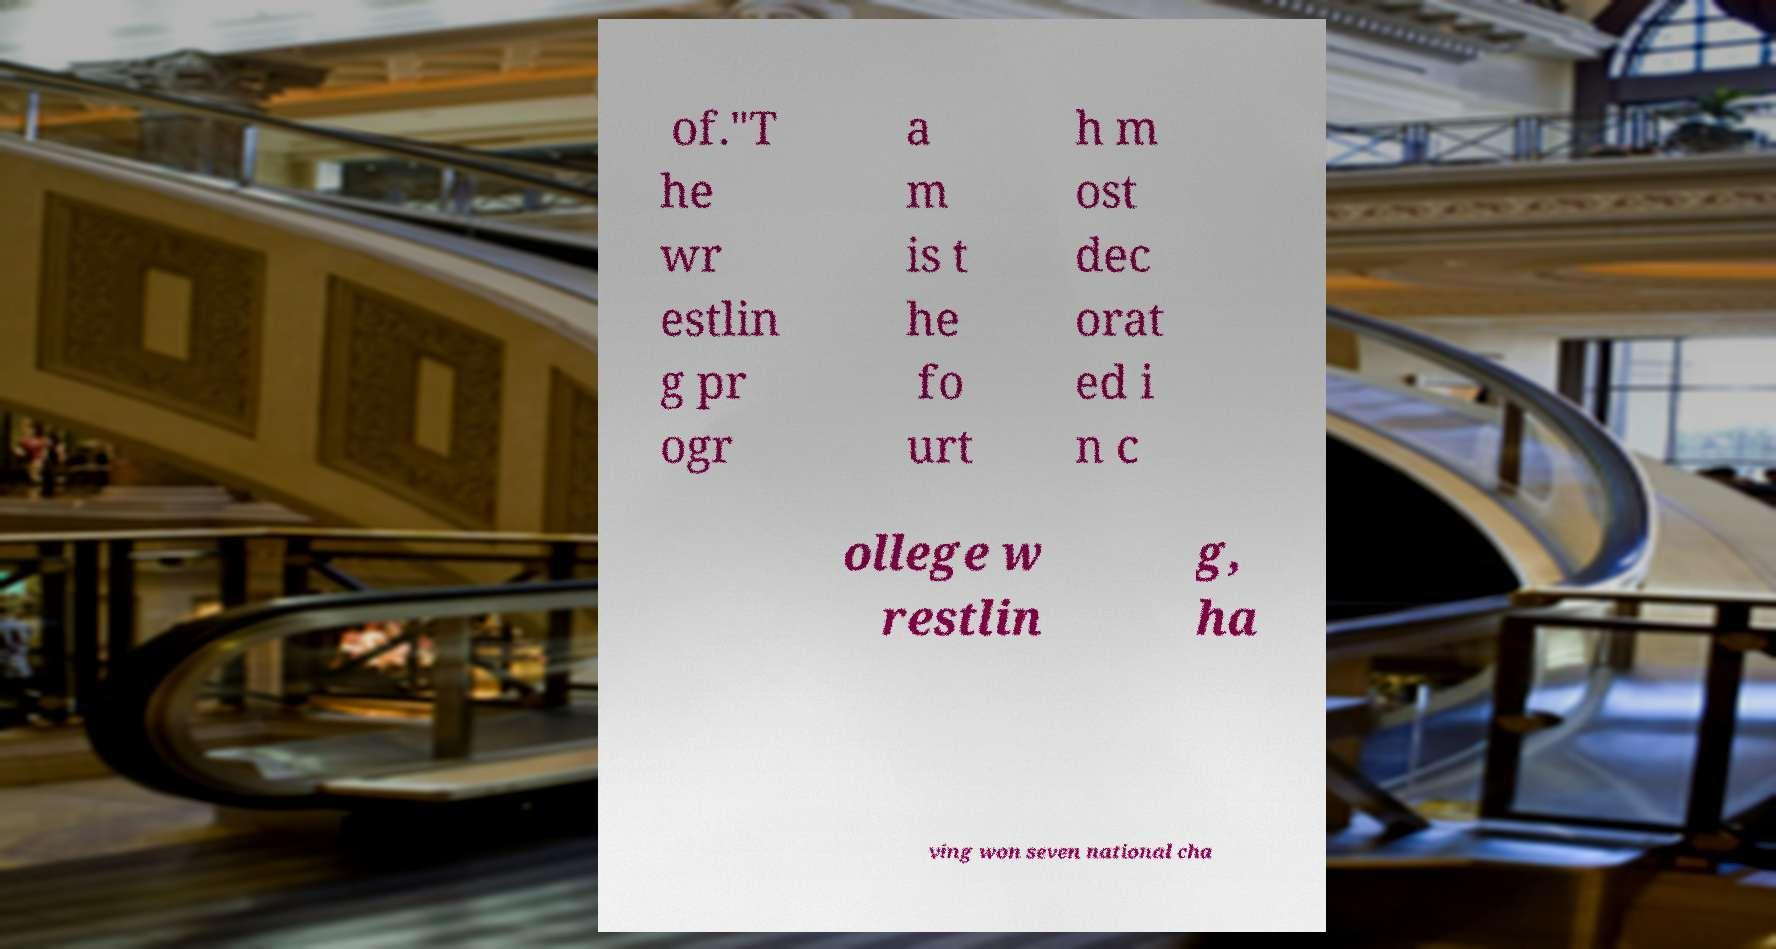I need the written content from this picture converted into text. Can you do that? of."T he wr estlin g pr ogr a m is t he fo urt h m ost dec orat ed i n c ollege w restlin g, ha ving won seven national cha 